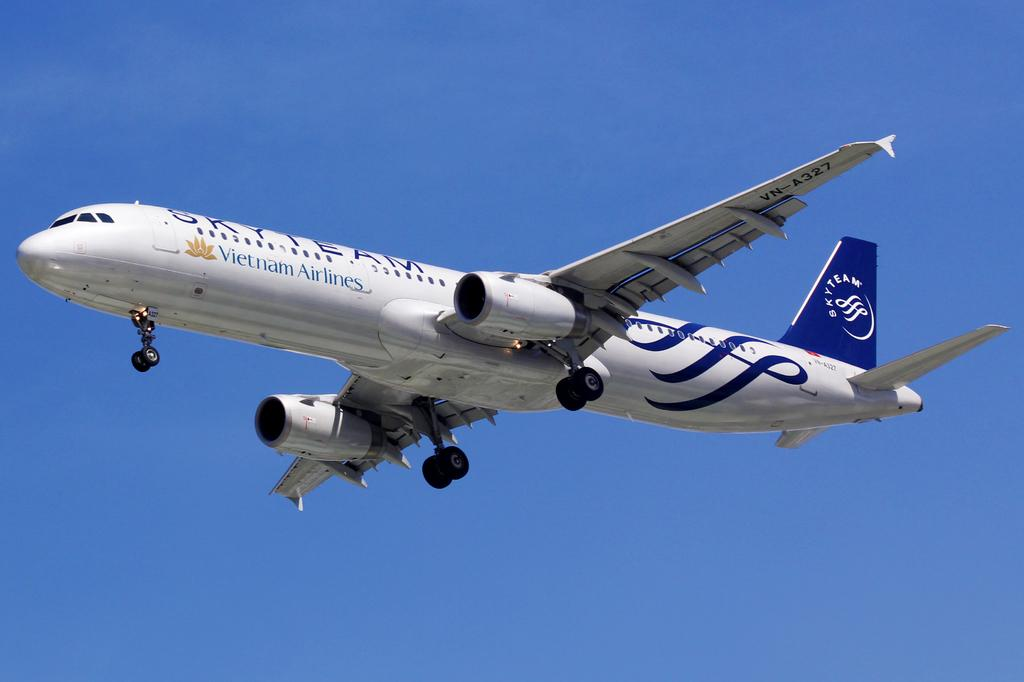What is the main subject of the image? The main subject of the image is an aircraft. Where is the aircraft located in the image? The aircraft is in the sky. How many eggs are on the table in the image? There is no table or eggs present in the image; it features an aircraft in the sky. What type of respect is shown towards the aircraft in the image? There is no indication of respect or any human interaction in the image, as it only shows an aircraft in the sky. 